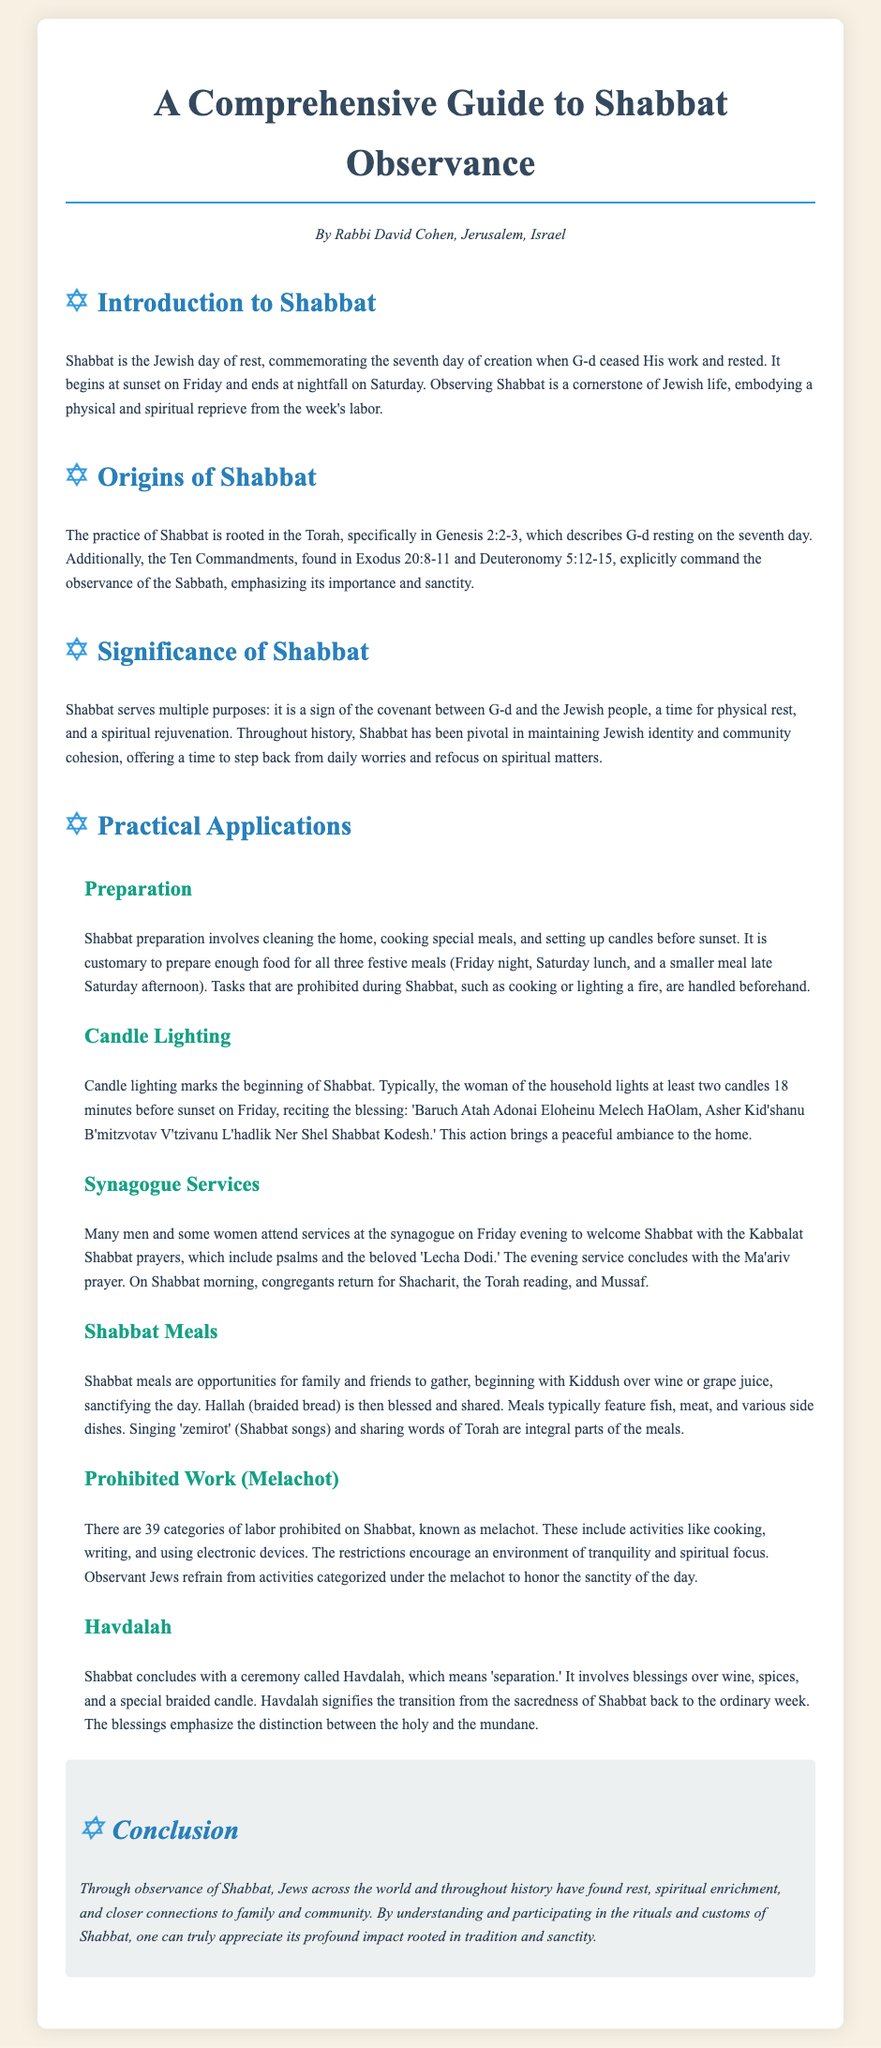What is the Jewish day of rest? The document states that Shabbat is the Jewish day of rest, commemorating the seventh day of creation.
Answer: Shabbat What are the two main biblical sources for the observance of Shabbat? The document cites Genesis 2:2-3 and the Ten Commandments from Exodus 20:8-11 and Deuteronomy 5:12-15 as the sources for Shabbat observance.
Answer: Genesis 2:2-3 and Exodus 20:8-11 How many categories of prohibited work are there on Shabbat? The document mentions that there are 39 categories of labor prohibited on Shabbat, known as melachot.
Answer: 39 What marking signifies the beginning of Shabbat? The document indicates that candle lighting marks the beginning of Shabbat.
Answer: Candle lighting What is the purpose of Havdalah? The document explains that Havdalah signifies the transition from the sacredness of Shabbat back to the ordinary week.
Answer: Transition from the sacredness of Shabbat Which prayer service is held at the synagogue on Friday evening? The document states that the Kabbalat Shabbat prayers are held on Friday evening to welcome Shabbat.
Answer: Kabbalat Shabbat What type of meals are typically eaten during Shabbat? According to the document, Shabbat meals begin with Kiddush and typically feature fish, meat, and various side dishes.
Answer: Fish, meat, and various side dishes Who usually lights the Shabbat candles? The document notes that typically, the woman of the household lights the Shabbat candles.
Answer: The woman of the household What does Kiddush sanctify? The document mentions that Kiddush sanctifies the day of Shabbat.
Answer: The day of Shabbat 